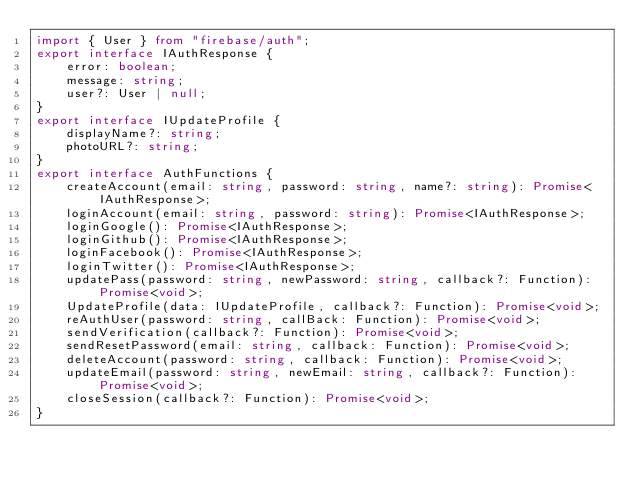Convert code to text. <code><loc_0><loc_0><loc_500><loc_500><_TypeScript_>import { User } from "firebase/auth";
export interface IAuthResponse {
    error: boolean;
    message: string;
    user?: User | null;
}
export interface IUpdateProfile {
    displayName?: string;
    photoURL?: string;
}
export interface AuthFunctions {
    createAccount(email: string, password: string, name?: string): Promise<IAuthResponse>;
    loginAccount(email: string, password: string): Promise<IAuthResponse>;
    loginGoogle(): Promise<IAuthResponse>;
    loginGithub(): Promise<IAuthResponse>;
    loginFacebook(): Promise<IAuthResponse>;
    loginTwitter(): Promise<IAuthResponse>;
    updatePass(password: string, newPassword: string, callback?: Function): Promise<void>;
    UpdateProfile(data: IUpdateProfile, callback?: Function): Promise<void>;
    reAuthUser(password: string, callBack: Function): Promise<void>;
    sendVerification(callback?: Function): Promise<void>;
    sendResetPassword(email: string, callback: Function): Promise<void>;
    deleteAccount(password: string, callback: Function): Promise<void>;
    updateEmail(password: string, newEmail: string, callback?: Function): Promise<void>;
    closeSession(callback?: Function): Promise<void>;
}
</code> 